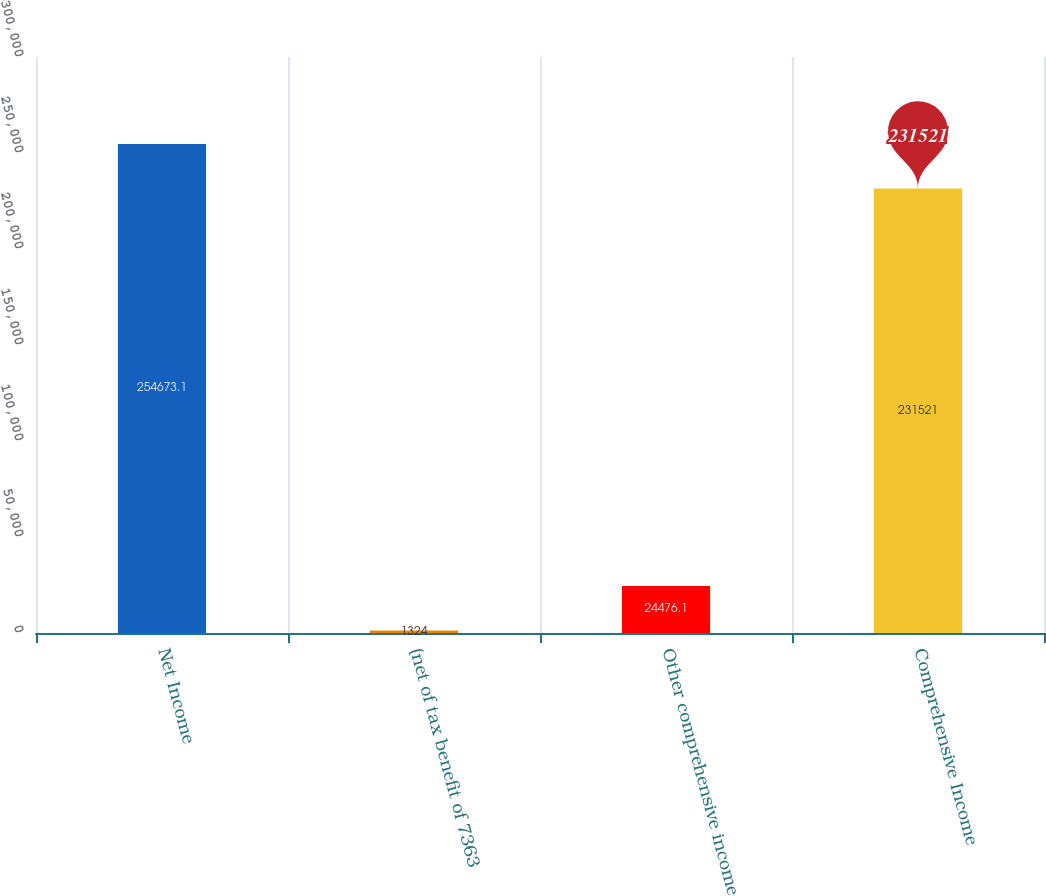<chart> <loc_0><loc_0><loc_500><loc_500><bar_chart><fcel>Net Income<fcel>(net of tax benefit of 7363<fcel>Other comprehensive income<fcel>Comprehensive Income<nl><fcel>254673<fcel>1324<fcel>24476.1<fcel>231521<nl></chart> 